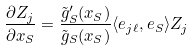<formula> <loc_0><loc_0><loc_500><loc_500>\frac { \partial Z _ { j } } { \partial x _ { S } } = \frac { { \tilde { g } } _ { S } ^ { \prime } ( x _ { S } ) } { { \tilde { g } } _ { S } ( x _ { S } ) } \langle e _ { j \ell } , e _ { S } \rangle Z _ { j }</formula> 